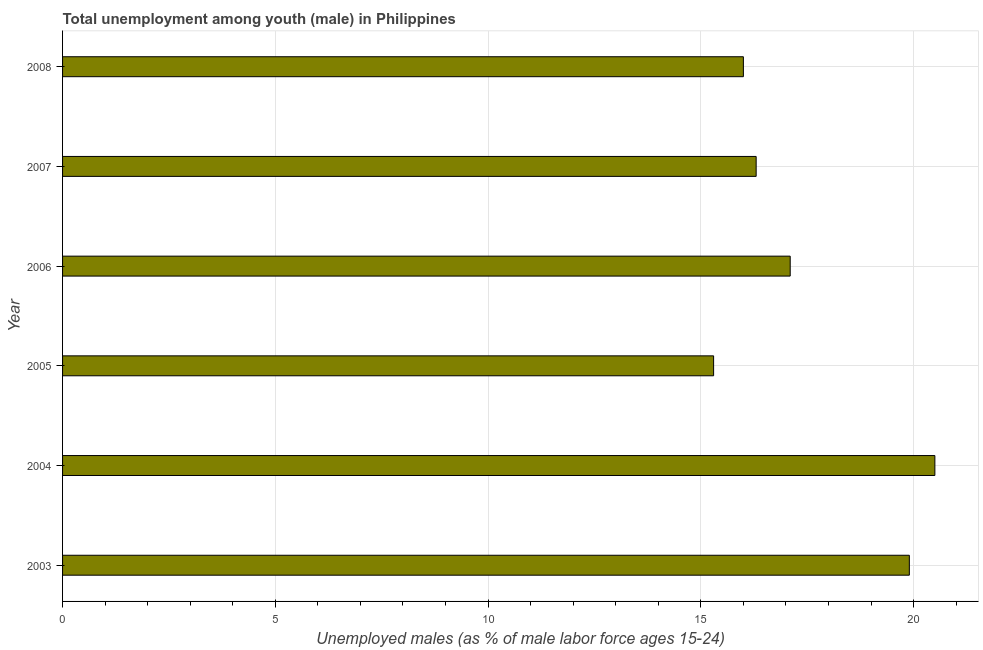Does the graph contain any zero values?
Offer a very short reply. No. Does the graph contain grids?
Provide a succinct answer. Yes. What is the title of the graph?
Your response must be concise. Total unemployment among youth (male) in Philippines. What is the label or title of the X-axis?
Ensure brevity in your answer.  Unemployed males (as % of male labor force ages 15-24). What is the unemployed male youth population in 2003?
Provide a succinct answer. 19.9. Across all years, what is the maximum unemployed male youth population?
Your answer should be very brief. 20.5. Across all years, what is the minimum unemployed male youth population?
Offer a terse response. 15.3. What is the sum of the unemployed male youth population?
Offer a terse response. 105.1. What is the difference between the unemployed male youth population in 2003 and 2004?
Offer a terse response. -0.6. What is the average unemployed male youth population per year?
Provide a succinct answer. 17.52. What is the median unemployed male youth population?
Keep it short and to the point. 16.7. Do a majority of the years between 2008 and 2007 (inclusive) have unemployed male youth population greater than 16 %?
Make the answer very short. No. What is the ratio of the unemployed male youth population in 2003 to that in 2005?
Your answer should be very brief. 1.3. What is the difference between the highest and the second highest unemployed male youth population?
Your response must be concise. 0.6. What is the difference between the highest and the lowest unemployed male youth population?
Offer a terse response. 5.2. Are all the bars in the graph horizontal?
Your answer should be very brief. Yes. How many years are there in the graph?
Ensure brevity in your answer.  6. What is the difference between two consecutive major ticks on the X-axis?
Provide a succinct answer. 5. What is the Unemployed males (as % of male labor force ages 15-24) of 2003?
Offer a terse response. 19.9. What is the Unemployed males (as % of male labor force ages 15-24) of 2005?
Your response must be concise. 15.3. What is the Unemployed males (as % of male labor force ages 15-24) in 2006?
Give a very brief answer. 17.1. What is the Unemployed males (as % of male labor force ages 15-24) in 2007?
Provide a short and direct response. 16.3. What is the difference between the Unemployed males (as % of male labor force ages 15-24) in 2003 and 2005?
Your answer should be very brief. 4.6. What is the difference between the Unemployed males (as % of male labor force ages 15-24) in 2003 and 2006?
Offer a very short reply. 2.8. What is the difference between the Unemployed males (as % of male labor force ages 15-24) in 2003 and 2007?
Your answer should be very brief. 3.6. What is the difference between the Unemployed males (as % of male labor force ages 15-24) in 2004 and 2008?
Your response must be concise. 4.5. What is the difference between the Unemployed males (as % of male labor force ages 15-24) in 2005 and 2006?
Provide a short and direct response. -1.8. What is the difference between the Unemployed males (as % of male labor force ages 15-24) in 2005 and 2008?
Make the answer very short. -0.7. What is the difference between the Unemployed males (as % of male labor force ages 15-24) in 2006 and 2007?
Your answer should be very brief. 0.8. What is the ratio of the Unemployed males (as % of male labor force ages 15-24) in 2003 to that in 2004?
Offer a terse response. 0.97. What is the ratio of the Unemployed males (as % of male labor force ages 15-24) in 2003 to that in 2005?
Your answer should be compact. 1.3. What is the ratio of the Unemployed males (as % of male labor force ages 15-24) in 2003 to that in 2006?
Make the answer very short. 1.16. What is the ratio of the Unemployed males (as % of male labor force ages 15-24) in 2003 to that in 2007?
Your response must be concise. 1.22. What is the ratio of the Unemployed males (as % of male labor force ages 15-24) in 2003 to that in 2008?
Make the answer very short. 1.24. What is the ratio of the Unemployed males (as % of male labor force ages 15-24) in 2004 to that in 2005?
Your answer should be very brief. 1.34. What is the ratio of the Unemployed males (as % of male labor force ages 15-24) in 2004 to that in 2006?
Offer a very short reply. 1.2. What is the ratio of the Unemployed males (as % of male labor force ages 15-24) in 2004 to that in 2007?
Give a very brief answer. 1.26. What is the ratio of the Unemployed males (as % of male labor force ages 15-24) in 2004 to that in 2008?
Your answer should be very brief. 1.28. What is the ratio of the Unemployed males (as % of male labor force ages 15-24) in 2005 to that in 2006?
Make the answer very short. 0.9. What is the ratio of the Unemployed males (as % of male labor force ages 15-24) in 2005 to that in 2007?
Offer a terse response. 0.94. What is the ratio of the Unemployed males (as % of male labor force ages 15-24) in 2005 to that in 2008?
Give a very brief answer. 0.96. What is the ratio of the Unemployed males (as % of male labor force ages 15-24) in 2006 to that in 2007?
Your response must be concise. 1.05. What is the ratio of the Unemployed males (as % of male labor force ages 15-24) in 2006 to that in 2008?
Ensure brevity in your answer.  1.07. What is the ratio of the Unemployed males (as % of male labor force ages 15-24) in 2007 to that in 2008?
Provide a short and direct response. 1.02. 